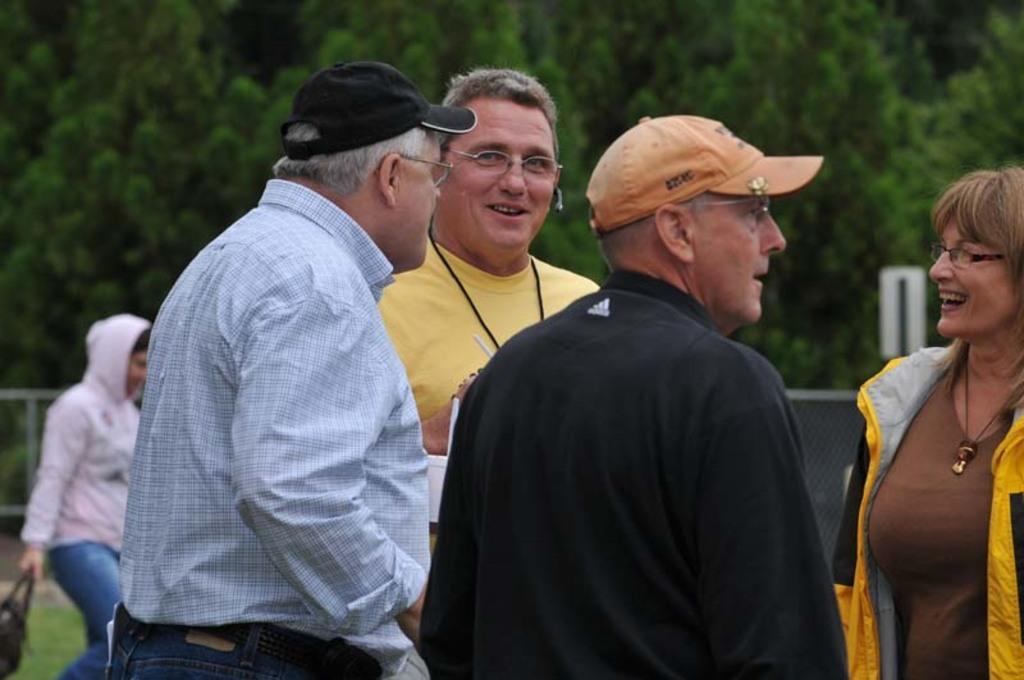Describe this image in one or two sentences. In this image we can see a few people, there is a person holding a bag and walking, there is a fencing, and trees, also we can see the background is blurred. 